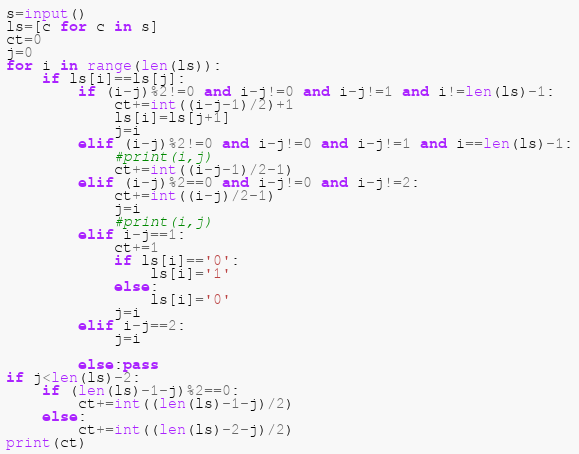<code> <loc_0><loc_0><loc_500><loc_500><_Python_>s=input()
ls=[c for c in s]
ct=0
j=0
for i in range(len(ls)):
    if ls[i]==ls[j]:
        if (i-j)%2!=0 and i-j!=0 and i-j!=1 and i!=len(ls)-1:
            ct+=int((i-j-1)/2)+1
            ls[i]=ls[j+1]
            j=i
        elif (i-j)%2!=0 and i-j!=0 and i-j!=1 and i==len(ls)-1:
            #print(i,j)
            ct+=int((i-j-1)/2-1)
        elif (i-j)%2==0 and i-j!=0 and i-j!=2:
            ct+=int((i-j)/2-1)
            j=i
            #print(i,j)
        elif i-j==1:
            ct+=1
            if ls[i]=='0':
                ls[i]='1'
            else:
                ls[i]='0'
            j=i
        elif i-j==2:
            j=i
            
        else:pass
if j<len(ls)-2:
    if (len(ls)-1-j)%2==0:
        ct+=int((len(ls)-1-j)/2)
    else:
        ct+=int((len(ls)-2-j)/2)
print(ct)</code> 